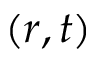Convert formula to latex. <formula><loc_0><loc_0><loc_500><loc_500>( r , t )</formula> 